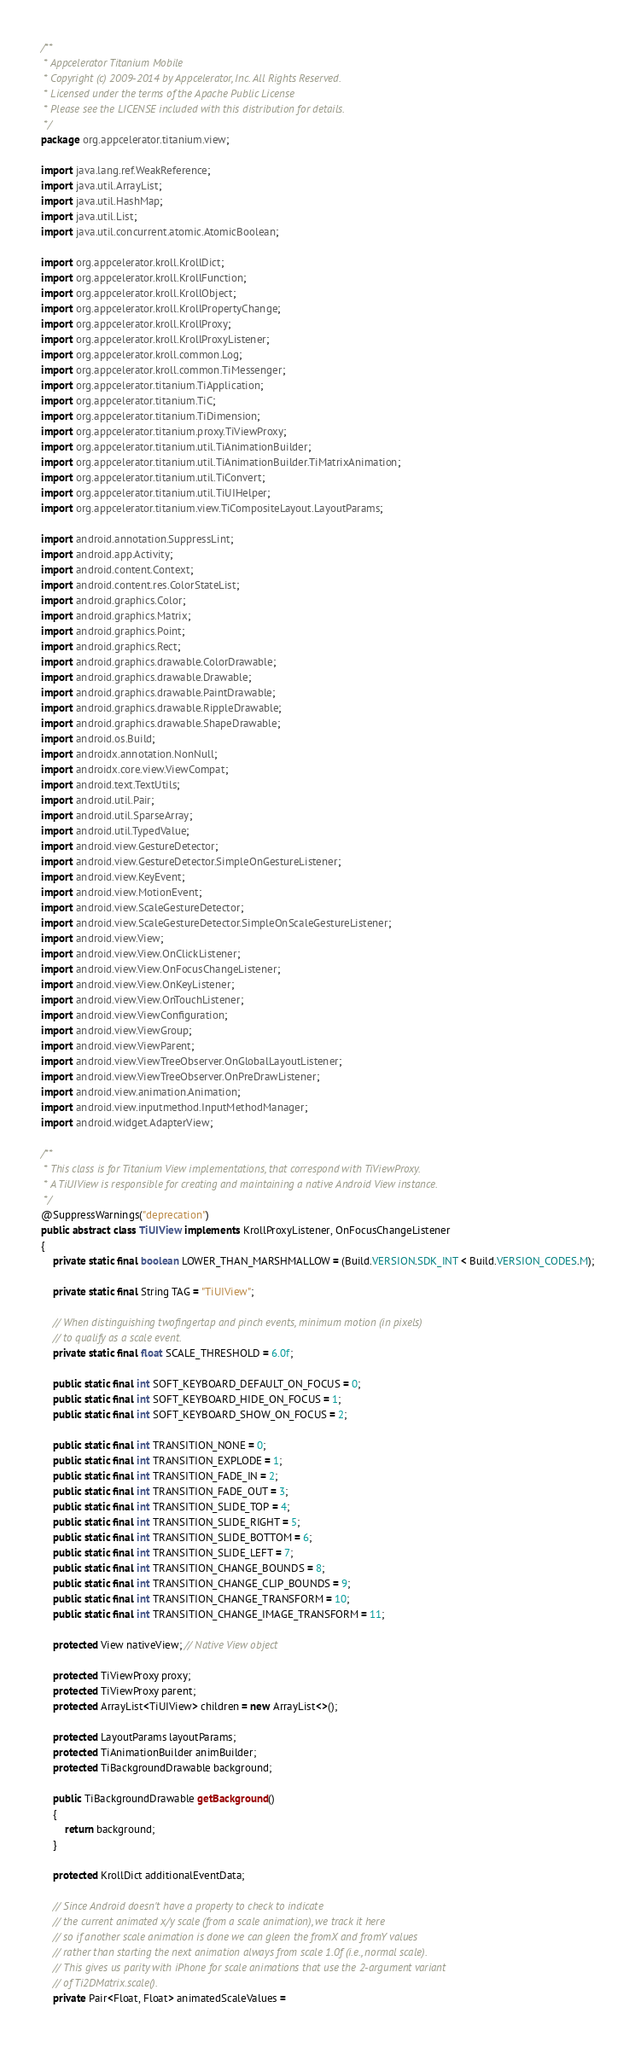Convert code to text. <code><loc_0><loc_0><loc_500><loc_500><_Java_>/**
 * Appcelerator Titanium Mobile
 * Copyright (c) 2009-2014 by Appcelerator, Inc. All Rights Reserved.
 * Licensed under the terms of the Apache Public License
 * Please see the LICENSE included with this distribution for details.
 */
package org.appcelerator.titanium.view;

import java.lang.ref.WeakReference;
import java.util.ArrayList;
import java.util.HashMap;
import java.util.List;
import java.util.concurrent.atomic.AtomicBoolean;

import org.appcelerator.kroll.KrollDict;
import org.appcelerator.kroll.KrollFunction;
import org.appcelerator.kroll.KrollObject;
import org.appcelerator.kroll.KrollPropertyChange;
import org.appcelerator.kroll.KrollProxy;
import org.appcelerator.kroll.KrollProxyListener;
import org.appcelerator.kroll.common.Log;
import org.appcelerator.kroll.common.TiMessenger;
import org.appcelerator.titanium.TiApplication;
import org.appcelerator.titanium.TiC;
import org.appcelerator.titanium.TiDimension;
import org.appcelerator.titanium.proxy.TiViewProxy;
import org.appcelerator.titanium.util.TiAnimationBuilder;
import org.appcelerator.titanium.util.TiAnimationBuilder.TiMatrixAnimation;
import org.appcelerator.titanium.util.TiConvert;
import org.appcelerator.titanium.util.TiUIHelper;
import org.appcelerator.titanium.view.TiCompositeLayout.LayoutParams;

import android.annotation.SuppressLint;
import android.app.Activity;
import android.content.Context;
import android.content.res.ColorStateList;
import android.graphics.Color;
import android.graphics.Matrix;
import android.graphics.Point;
import android.graphics.Rect;
import android.graphics.drawable.ColorDrawable;
import android.graphics.drawable.Drawable;
import android.graphics.drawable.PaintDrawable;
import android.graphics.drawable.RippleDrawable;
import android.graphics.drawable.ShapeDrawable;
import android.os.Build;
import androidx.annotation.NonNull;
import androidx.core.view.ViewCompat;
import android.text.TextUtils;
import android.util.Pair;
import android.util.SparseArray;
import android.util.TypedValue;
import android.view.GestureDetector;
import android.view.GestureDetector.SimpleOnGestureListener;
import android.view.KeyEvent;
import android.view.MotionEvent;
import android.view.ScaleGestureDetector;
import android.view.ScaleGestureDetector.SimpleOnScaleGestureListener;
import android.view.View;
import android.view.View.OnClickListener;
import android.view.View.OnFocusChangeListener;
import android.view.View.OnKeyListener;
import android.view.View.OnTouchListener;
import android.view.ViewConfiguration;
import android.view.ViewGroup;
import android.view.ViewParent;
import android.view.ViewTreeObserver.OnGlobalLayoutListener;
import android.view.ViewTreeObserver.OnPreDrawListener;
import android.view.animation.Animation;
import android.view.inputmethod.InputMethodManager;
import android.widget.AdapterView;

/**
 * This class is for Titanium View implementations, that correspond with TiViewProxy.
 * A TiUIView is responsible for creating and maintaining a native Android View instance.
 */
@SuppressWarnings("deprecation")
public abstract class TiUIView implements KrollProxyListener, OnFocusChangeListener
{
	private static final boolean LOWER_THAN_MARSHMALLOW = (Build.VERSION.SDK_INT < Build.VERSION_CODES.M);

	private static final String TAG = "TiUIView";

	// When distinguishing twofingertap and pinch events, minimum motion (in pixels)
	// to qualify as a scale event.
	private static final float SCALE_THRESHOLD = 6.0f;

	public static final int SOFT_KEYBOARD_DEFAULT_ON_FOCUS = 0;
	public static final int SOFT_KEYBOARD_HIDE_ON_FOCUS = 1;
	public static final int SOFT_KEYBOARD_SHOW_ON_FOCUS = 2;

	public static final int TRANSITION_NONE = 0;
	public static final int TRANSITION_EXPLODE = 1;
	public static final int TRANSITION_FADE_IN = 2;
	public static final int TRANSITION_FADE_OUT = 3;
	public static final int TRANSITION_SLIDE_TOP = 4;
	public static final int TRANSITION_SLIDE_RIGHT = 5;
	public static final int TRANSITION_SLIDE_BOTTOM = 6;
	public static final int TRANSITION_SLIDE_LEFT = 7;
	public static final int TRANSITION_CHANGE_BOUNDS = 8;
	public static final int TRANSITION_CHANGE_CLIP_BOUNDS = 9;
	public static final int TRANSITION_CHANGE_TRANSFORM = 10;
	public static final int TRANSITION_CHANGE_IMAGE_TRANSFORM = 11;

	protected View nativeView; // Native View object

	protected TiViewProxy proxy;
	protected TiViewProxy parent;
	protected ArrayList<TiUIView> children = new ArrayList<>();

	protected LayoutParams layoutParams;
	protected TiAnimationBuilder animBuilder;
	protected TiBackgroundDrawable background;

	public TiBackgroundDrawable getBackground()
	{
		return background;
	}

	protected KrollDict additionalEventData;

	// Since Android doesn't have a property to check to indicate
	// the current animated x/y scale (from a scale animation), we track it here
	// so if another scale animation is done we can gleen the fromX and fromY values
	// rather than starting the next animation always from scale 1.0f (i.e., normal scale).
	// This gives us parity with iPhone for scale animations that use the 2-argument variant
	// of Ti2DMatrix.scale().
	private Pair<Float, Float> animatedScaleValues =</code> 